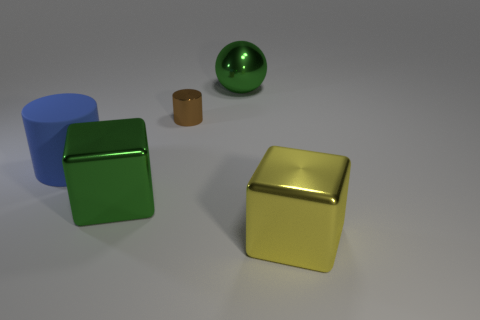Add 4 large green cubes. How many objects exist? 9 Subtract all blue cylinders. How many cylinders are left? 1 Add 5 cylinders. How many cylinders are left? 7 Add 4 large metal spheres. How many large metal spheres exist? 5 Subtract 1 green cubes. How many objects are left? 4 Subtract all balls. How many objects are left? 4 Subtract 1 cylinders. How many cylinders are left? 1 Subtract all green cylinders. Subtract all cyan blocks. How many cylinders are left? 2 Subtract all red spheres. How many gray blocks are left? 0 Subtract all tiny cyan metallic balls. Subtract all large green shiny blocks. How many objects are left? 4 